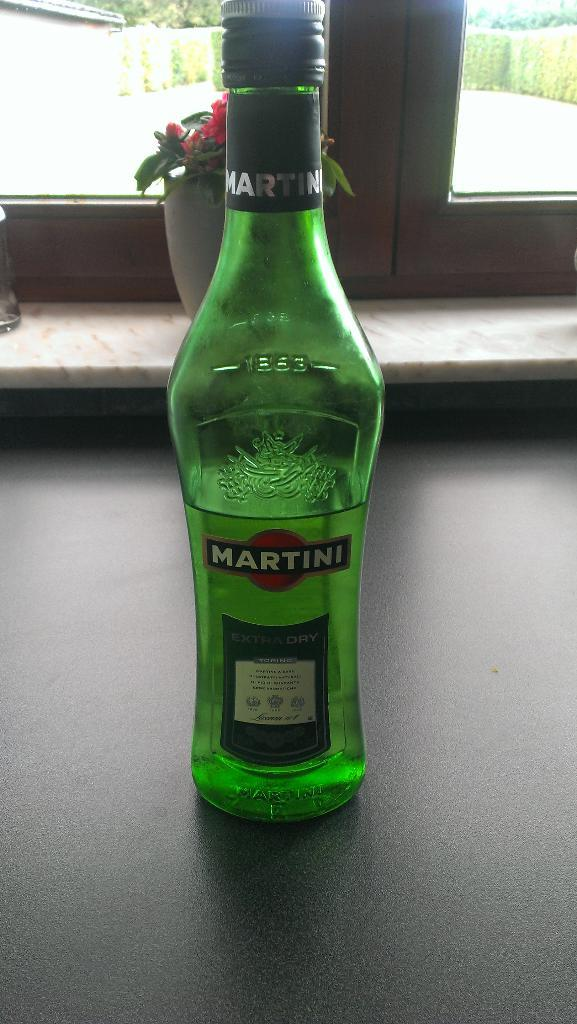<image>
Offer a succinct explanation of the picture presented. An empty green bottle of Martini branded drink is sitting on a table. 